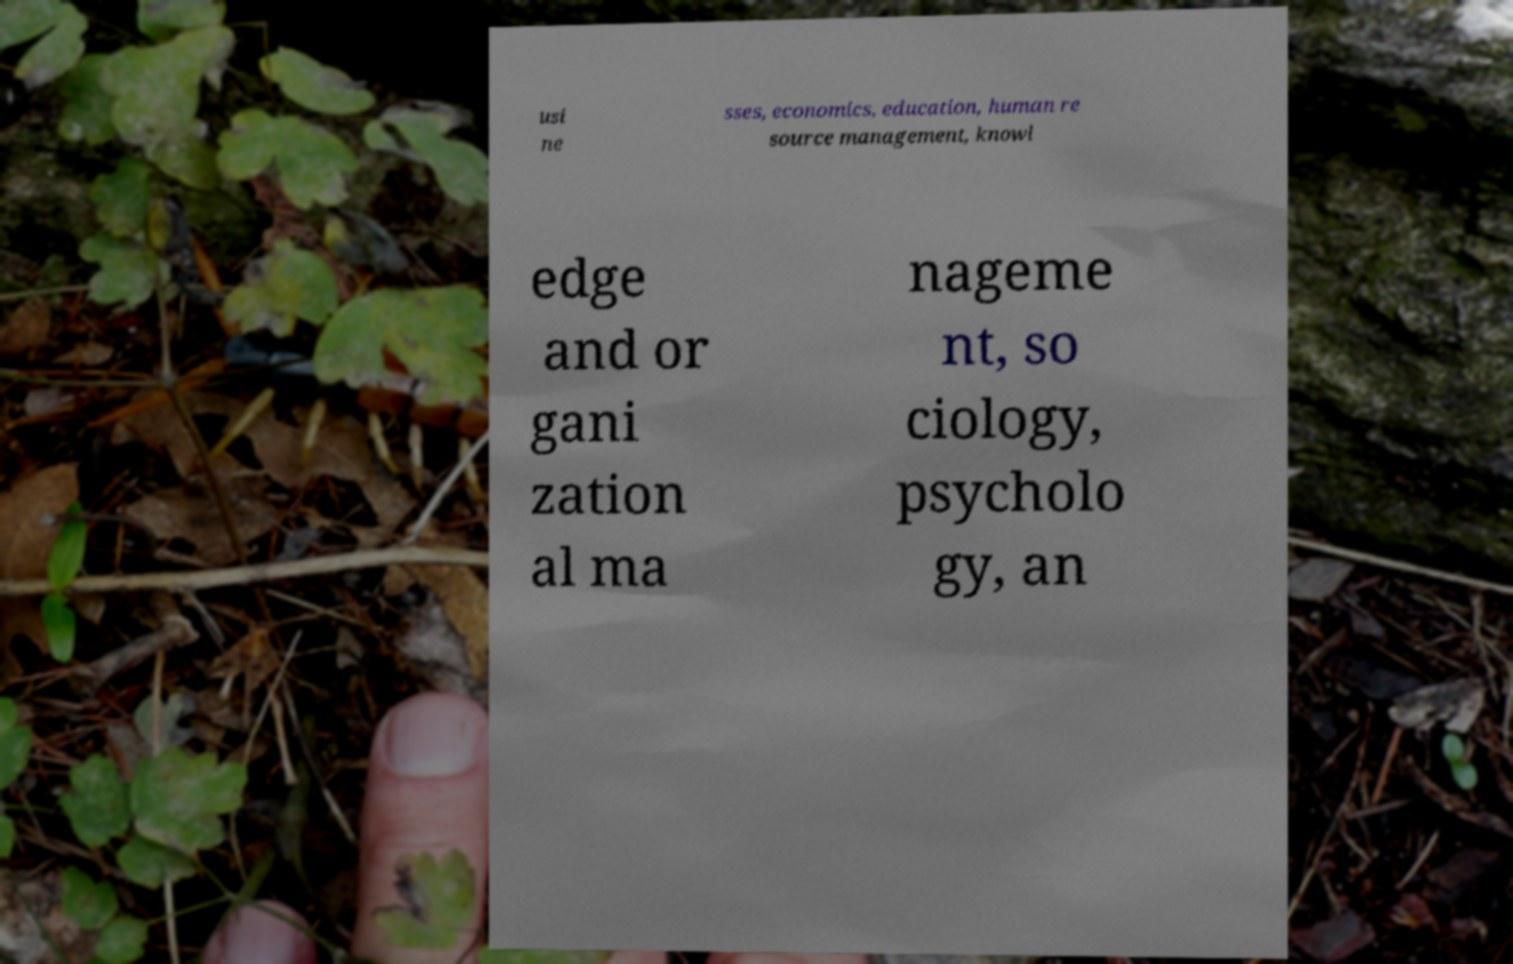Please read and relay the text visible in this image. What does it say? usi ne sses, economics, education, human re source management, knowl edge and or gani zation al ma nageme nt, so ciology, psycholo gy, an 